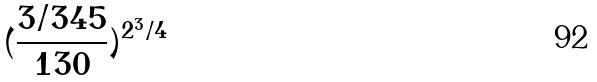Convert formula to latex. <formula><loc_0><loc_0><loc_500><loc_500>( \frac { 3 / 3 4 5 } { 1 3 0 } ) ^ { 2 ^ { 3 } / 4 }</formula> 